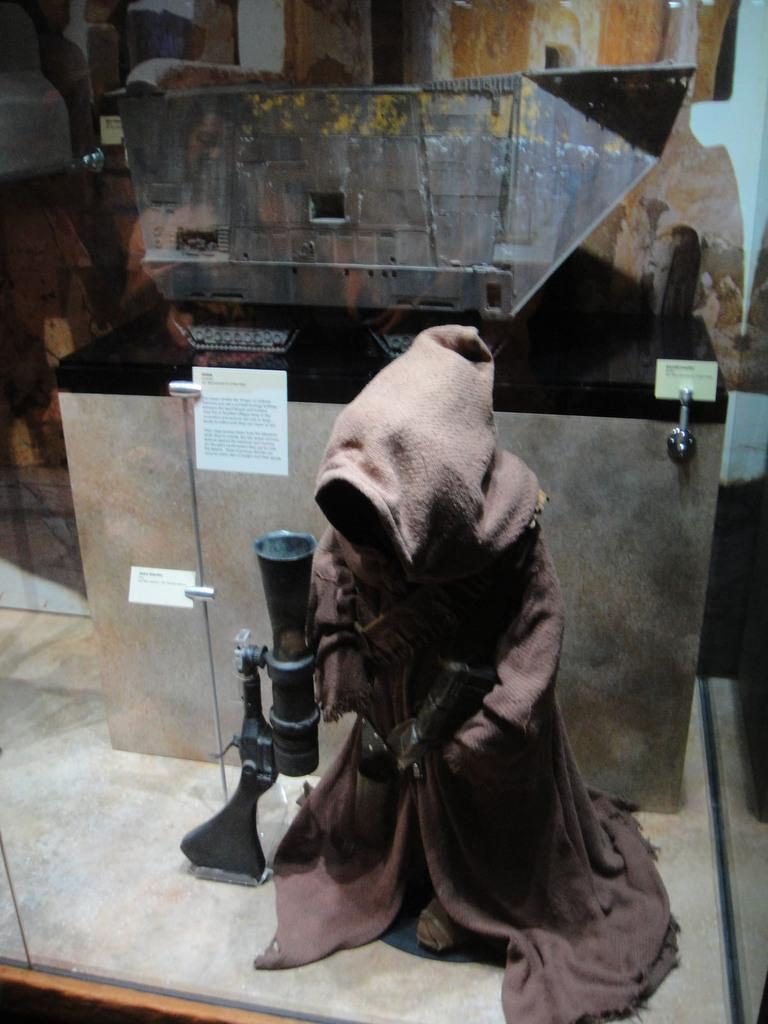What is the main subject in the foreground of the image? There is an undefined object in the foreground of the image. What can be observed about the appearance of the undefined object? The undefined object is wearing a dress. What can be seen in the background of the image? There is a paper in the background of the image. How many boats are visible in the image? There are no boats present in the image. What type of coach is standing next to the undefined object in the image? There is no coach present in the image. 